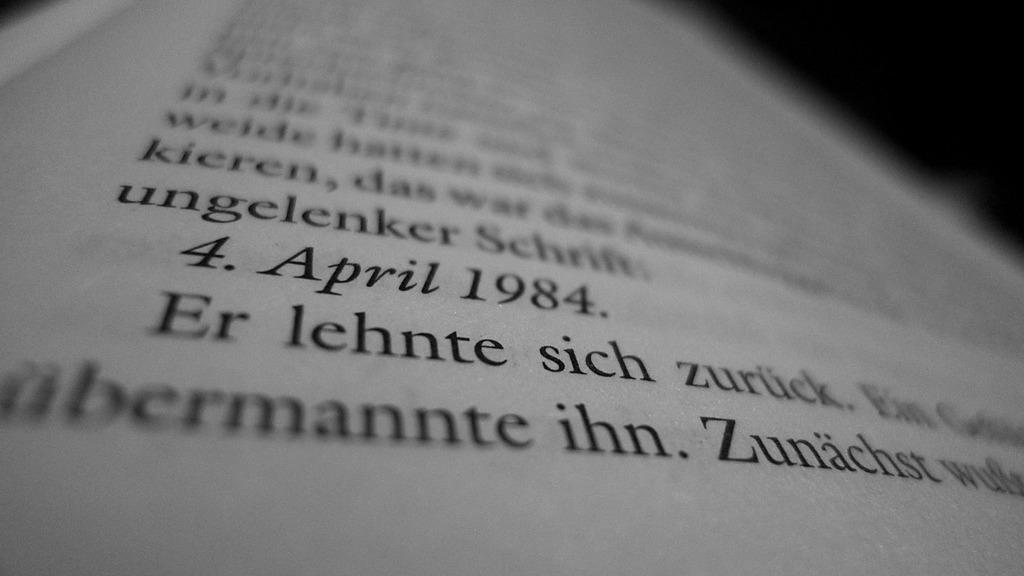<image>
Give a short and clear explanation of the subsequent image. A page with April 1984 printed on it 